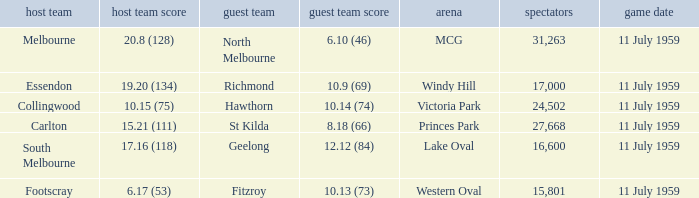What is the home team's score when richmond is away? 19.20 (134). 